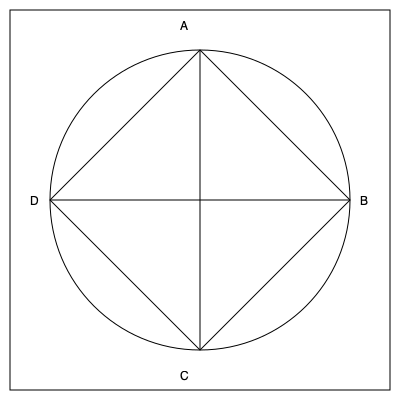In the context of online censorship, the geometric pattern above represents different types of content restrictions. If the square represents unrestricted internet access, the circle symbolizes partial censorship, and the diamond shape indicates complete censorship, what would be the result of rotating the entire pattern 90 degrees clockwise in terms of censorship levels from top to bottom? To solve this problem, we need to follow these steps:

1. Understand the initial configuration:
   - Top (A): Intersection of square and circle (partial censorship)
   - Right (B): Intersection of square, circle, and diamond (complete censorship)
   - Bottom (C): Intersection of square and circle (partial censorship)
   - Left (D): Only square (unrestricted access)

2. Visualize the 90-degree clockwise rotation:
   - A moves to B
   - B moves to C
   - C moves to D
   - D moves to A

3. Analyze the new configuration after rotation:
   - New top (originally left): Only square (unrestricted access)
   - New right (originally top): Intersection of square and circle (partial censorship)
   - New bottom (originally right): Intersection of square, circle, and diamond (complete censorship)
   - New left (originally bottom): Intersection of square and circle (partial censorship)

4. Determine the censorship levels from top to bottom:
   - Top: Unrestricted access
   - Middle: Partial censorship
   - Bottom: Complete censorship

This rotation represents a progression from unrestricted internet access to complete censorship, mirroring the potential evolution of online restrictions in a society.
Answer: Unrestricted → Partial → Complete 